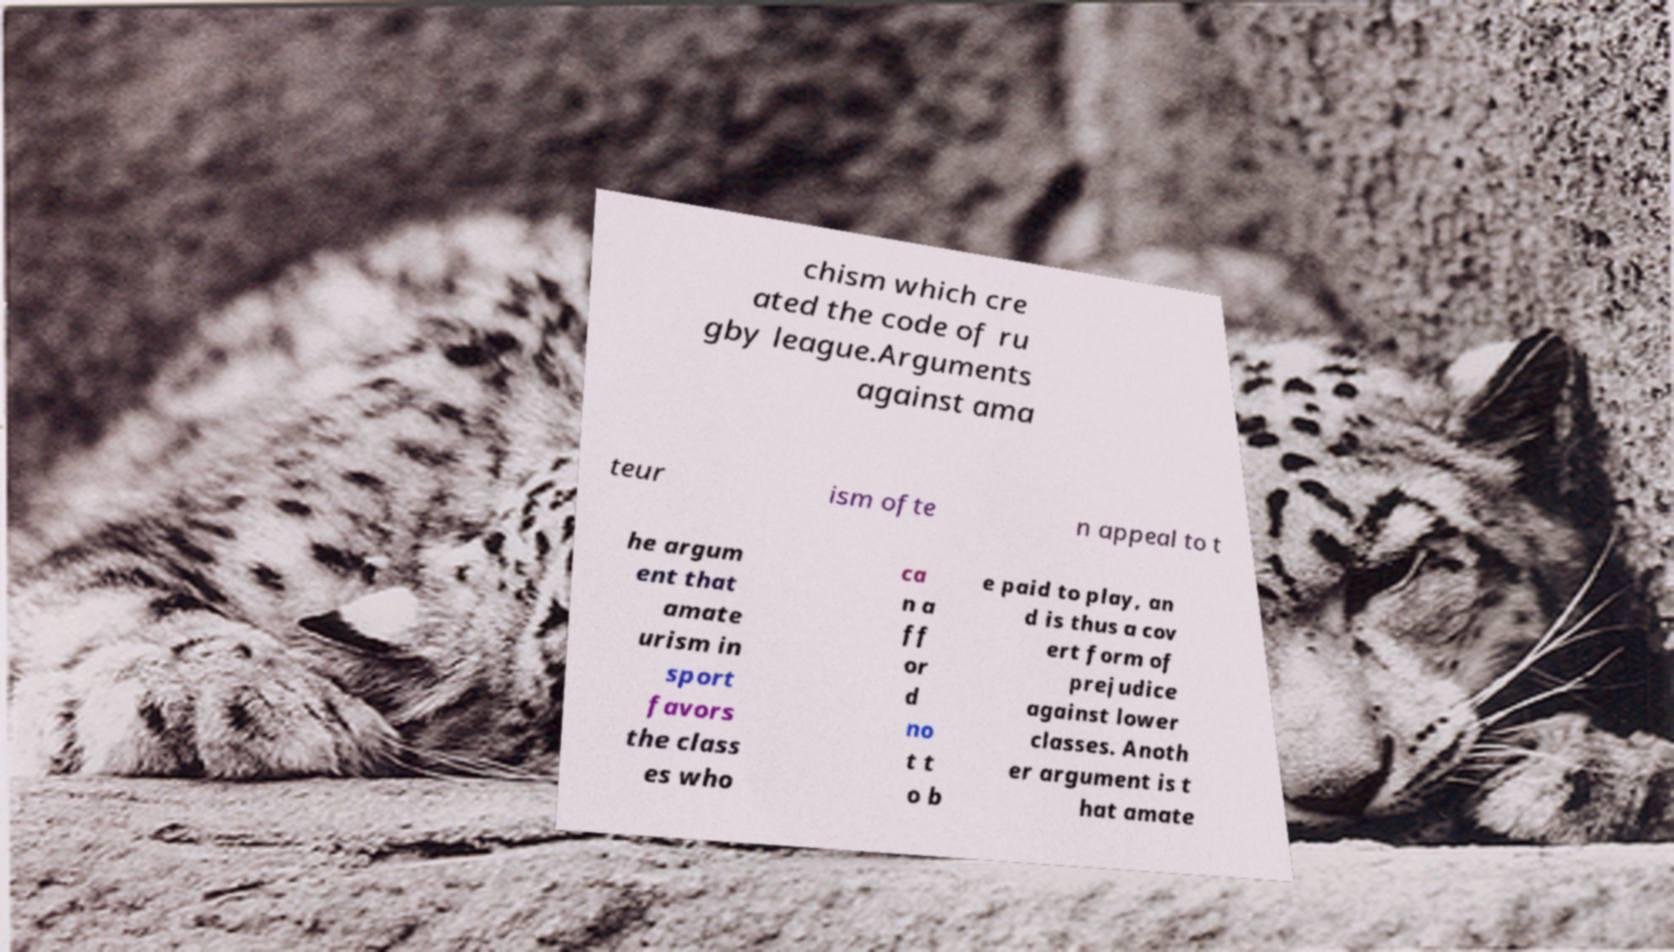What messages or text are displayed in this image? I need them in a readable, typed format. chism which cre ated the code of ru gby league.Arguments against ama teur ism ofte n appeal to t he argum ent that amate urism in sport favors the class es who ca n a ff or d no t t o b e paid to play, an d is thus a cov ert form of prejudice against lower classes. Anoth er argument is t hat amate 